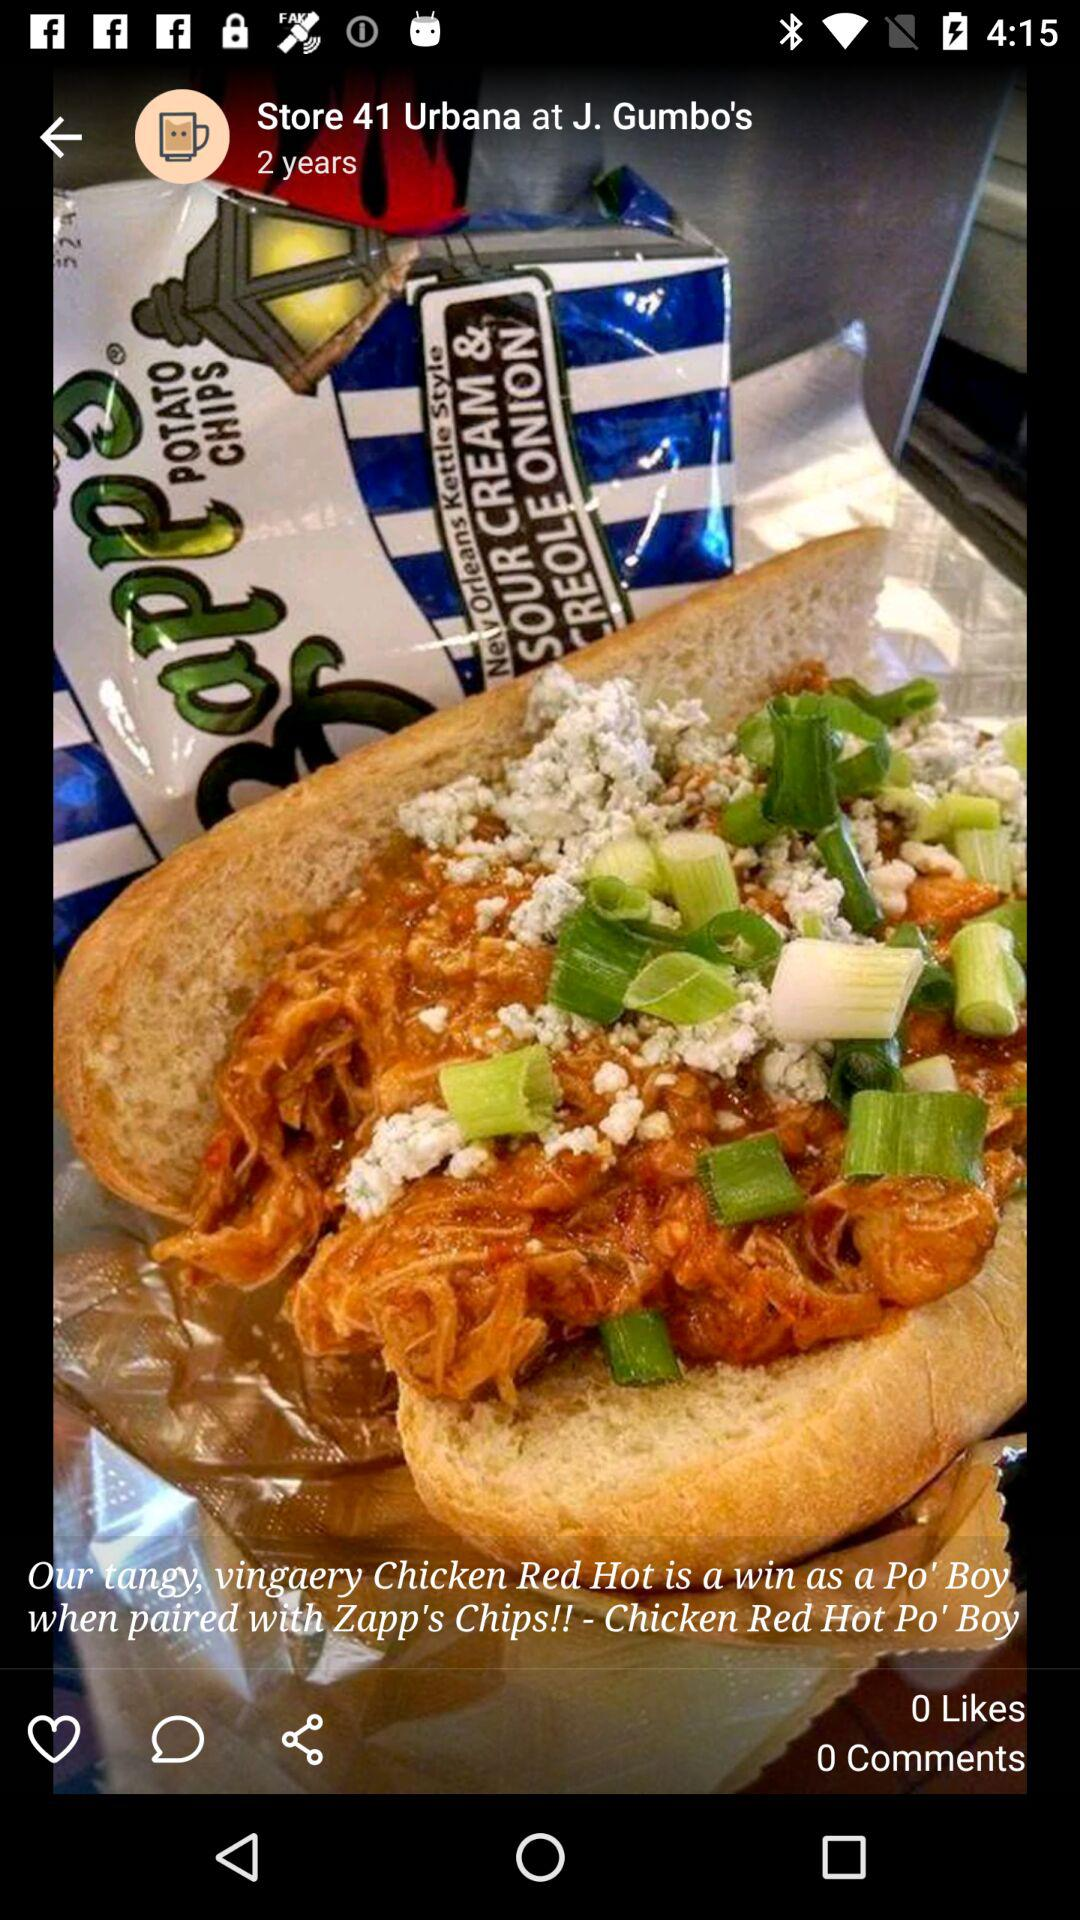When was the post posted? The post was posted two years ago. 